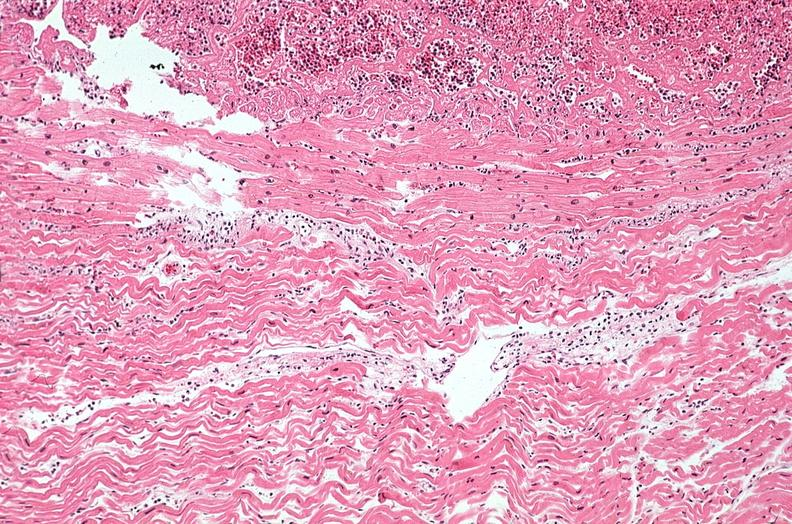does myocardium show heart, myocardial infarction, wavey fiber change, necrtosis, hemorrhage, and dissection?
Answer the question using a single word or phrase. No 